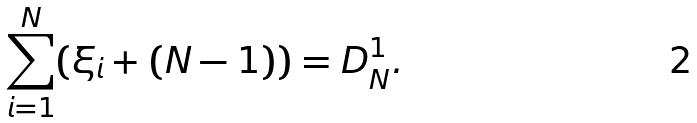Convert formula to latex. <formula><loc_0><loc_0><loc_500><loc_500>\sum _ { i = 1 } ^ { N } ( \xi _ { i } + ( N - 1 ) ) = D _ { N } ^ { 1 } .</formula> 